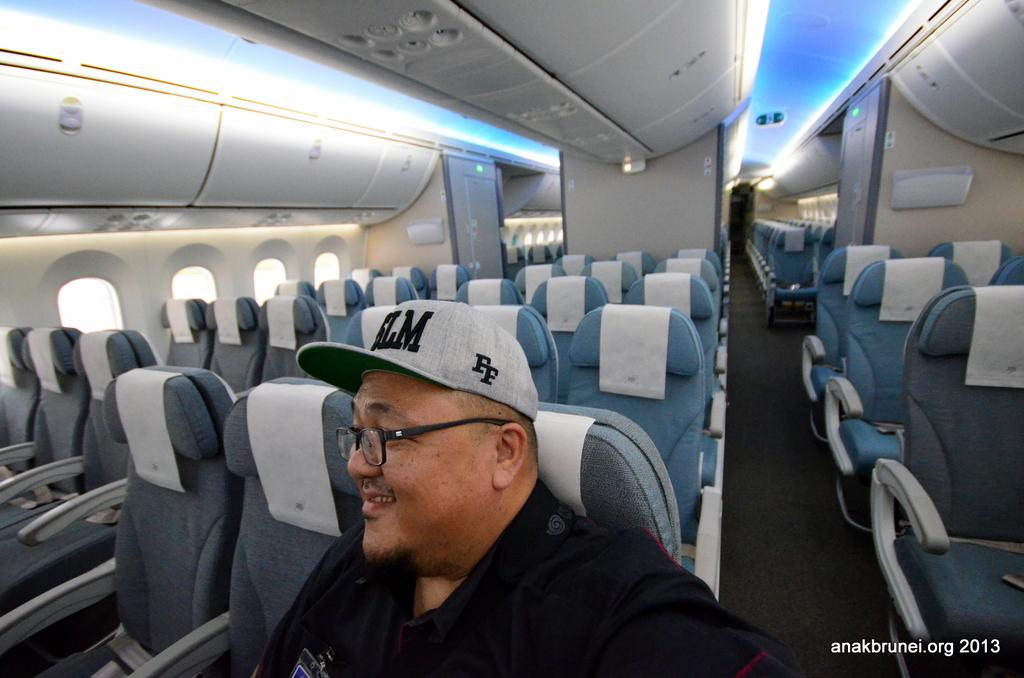<image>
Share a concise interpretation of the image provided. One man is shown on a otherwise empty airplane wearing a hat with FF embroidered on the side, in this photo that is identified as anakbrunei.org 2013. 